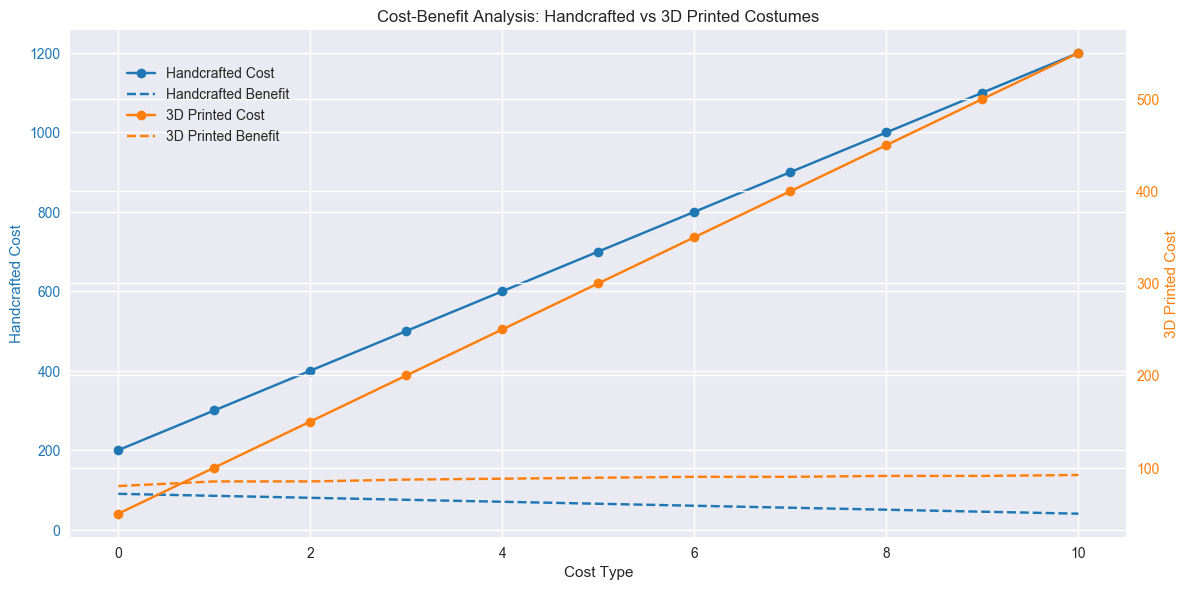What is the cost difference between handcrafted and 3D printed costumes at cost type 4? To find the difference, look for the cost at cost type 4 for both handcrafted (600) and 3D printed (250) costumes. Subtract the 3D printed cost from the handcrafted cost: 600 - 250 = 350.
Answer: 350 Which costume type sees a higher increase in cost from cost type 0 to cost type 10? Calculate the change in cost for handcrafted: 1200 - 200 = 1000, and for 3D printed: 550 - 50 = 500. The handcrafted cost increase is higher.
Answer: Handcrafted What is the benefit difference between handcrafted and 3D printed costumes at cost type 7? Look at cost type 7: the benefit for handcrafted is 55 and for 3D printed is 90. Subtract the handcrafted benefit from the 3D printed benefit: 90 - 55 = 35.
Answer: 35 At which cost type does the benefit of handcrafted costumes first drop below that of 3D printed costumes? Examine the benefits across the cost types. At cost type 0 and 1, handcrafted benefits are greater or equal. At cost type 2, the benefits of both are equal (85). At cost type 3, handcrafted benefits drop below 3D printed (75 vs. 87). The first instance is cost type 3.
Answer: Cost Type 3 Which line has a steeper slope, the handcrafted cost or the 3D printed cost? To determine the slope, observe the steepness of the lines visually. The handcrafted cost line (blue, solid) shows a steeper upward trend compared to the 3D printed cost line (orange, solid).
Answer: Handcrafted cost What is the average benefit for 3D printed costumes over all cost types? Sum up all the benefits for 3D printed: (80 + 85 + 85 + 87 + 88 + 89 + 90 + 90 + 91 + 91 + 92) = 968. Divide by the number of cost types (11), so 968 / 11 ≈ 88.
Answer: 88 What is the combined cost at cost type 5 for both handcrafted and 3D printed costumes? Add the costs of handcrafted (700) and 3D printed (300) costumes at cost type 5: 700 + 300 = 1000.
Answer: 1000 